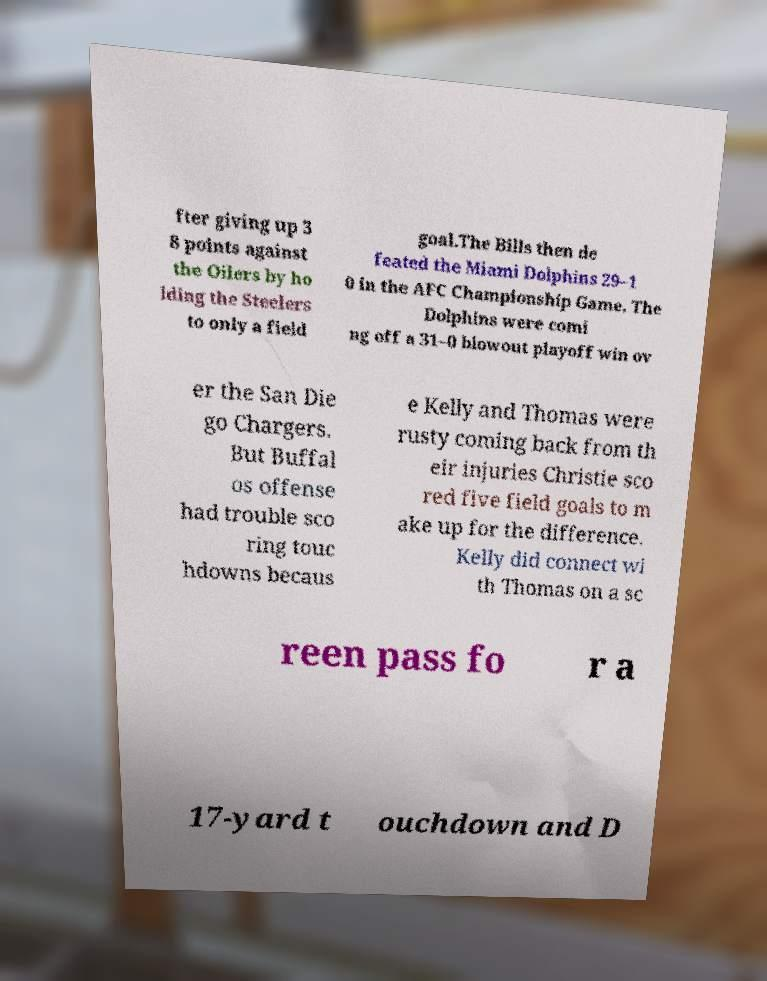Can you accurately transcribe the text from the provided image for me? fter giving up 3 8 points against the Oilers by ho lding the Steelers to only a field goal.The Bills then de feated the Miami Dolphins 29–1 0 in the AFC Championship Game. The Dolphins were comi ng off a 31–0 blowout playoff win ov er the San Die go Chargers. But Buffal os offense had trouble sco ring touc hdowns becaus e Kelly and Thomas were rusty coming back from th eir injuries Christie sco red five field goals to m ake up for the difference. Kelly did connect wi th Thomas on a sc reen pass fo r a 17-yard t ouchdown and D 